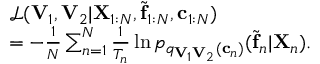<formula> <loc_0><loc_0><loc_500><loc_500>\begin{array} { r l } & { \mathcal { L } ( V _ { 1 } , V _ { 2 } | X _ { 1 \colon N } , \tilde { f } _ { 1 \colon N } , c _ { 1 \colon N } ) } \\ & { = - \frac { 1 } { N } \sum _ { n = 1 } ^ { N } \frac { 1 } { T _ { n } } \ln p _ { q _ { V _ { 1 } V _ { 2 } } ( c _ { n } ) } ( \tilde { f } _ { n } | X _ { n } ) . } \end{array}</formula> 